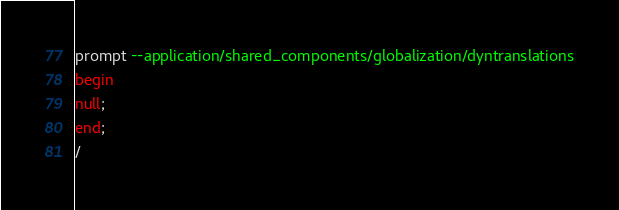<code> <loc_0><loc_0><loc_500><loc_500><_SQL_>prompt --application/shared_components/globalization/dyntranslationsbeginnull;end;/</code> 